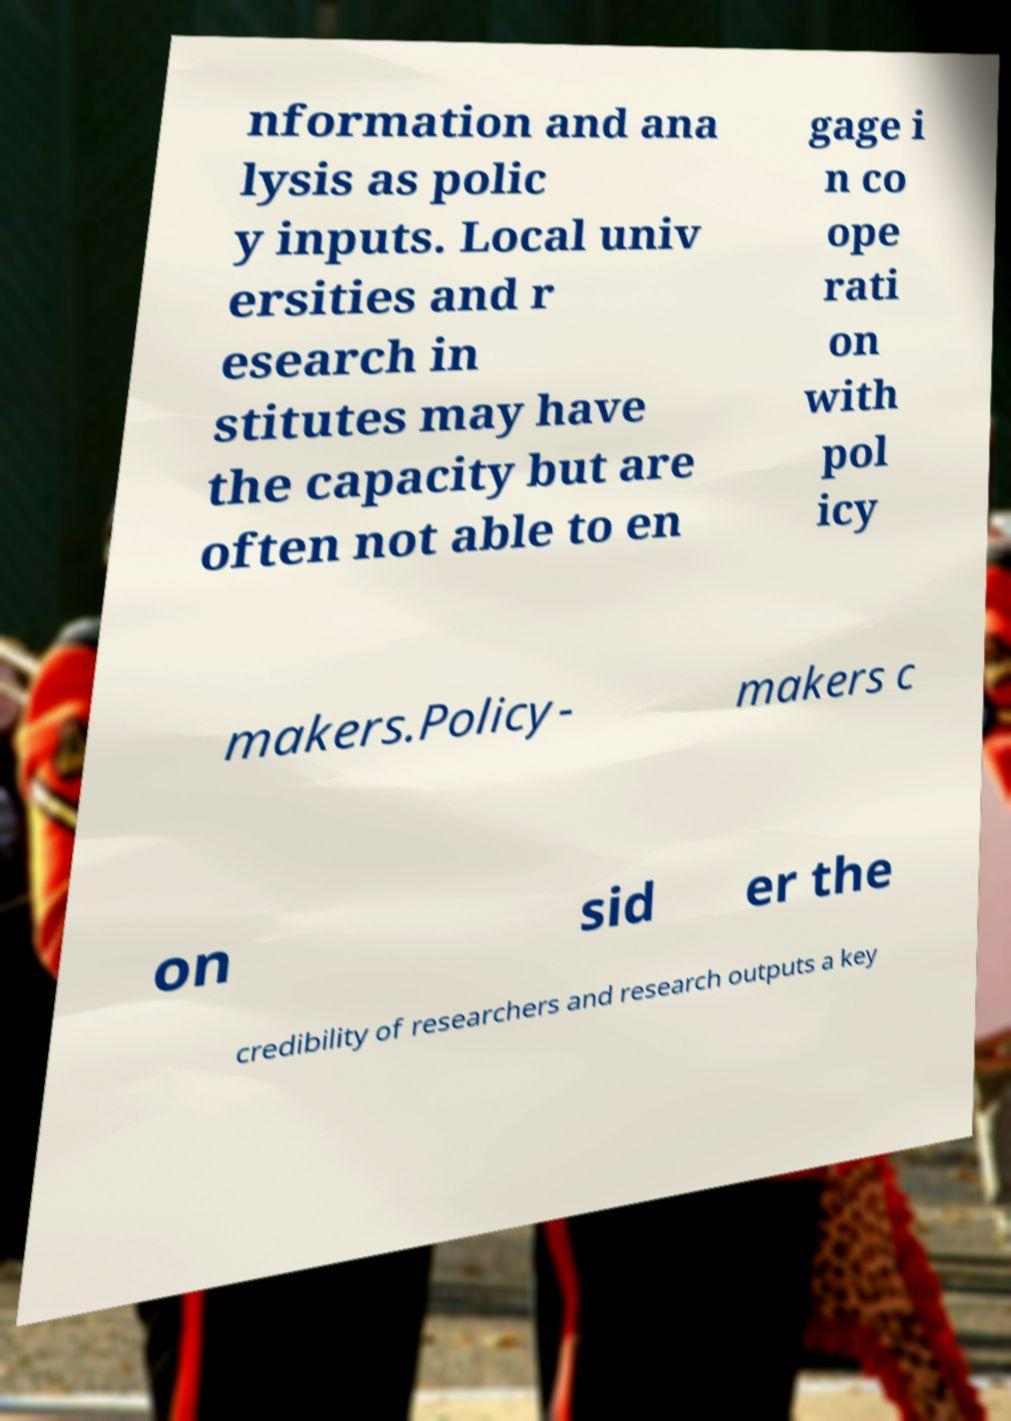I need the written content from this picture converted into text. Can you do that? nformation and ana lysis as polic y inputs. Local univ ersities and r esearch in stitutes may have the capacity but are often not able to en gage i n co ope rati on with pol icy makers.Policy- makers c on sid er the credibility of researchers and research outputs a key 